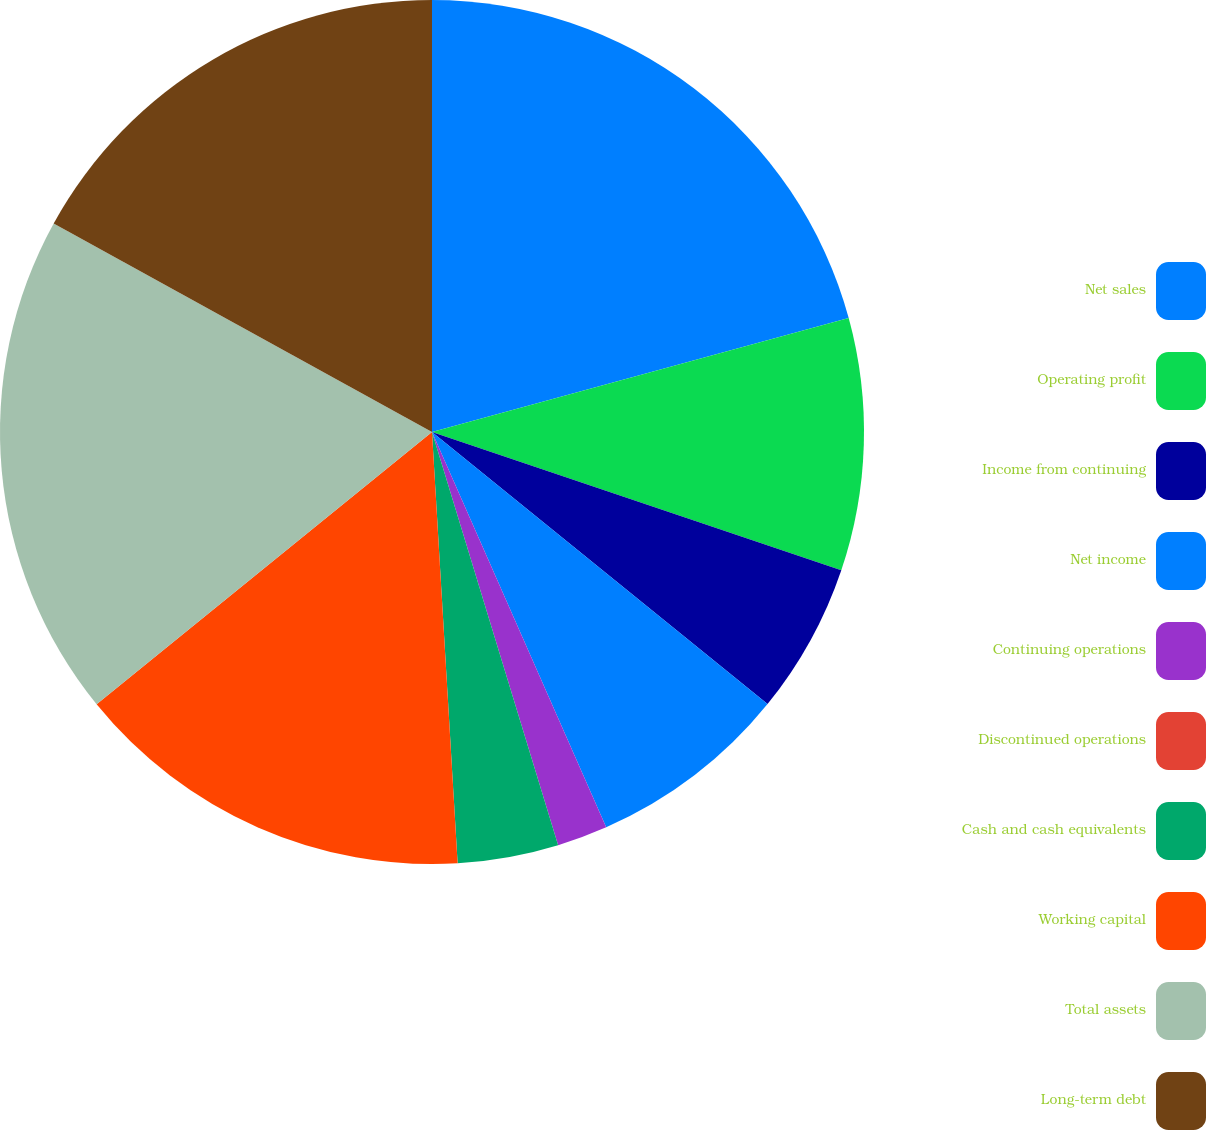Convert chart to OTSL. <chart><loc_0><loc_0><loc_500><loc_500><pie_chart><fcel>Net sales<fcel>Operating profit<fcel>Income from continuing<fcel>Net income<fcel>Continuing operations<fcel>Discontinued operations<fcel>Cash and cash equivalents<fcel>Working capital<fcel>Total assets<fcel>Long-term debt<nl><fcel>20.75%<fcel>9.43%<fcel>5.66%<fcel>7.55%<fcel>1.89%<fcel>0.0%<fcel>3.77%<fcel>15.09%<fcel>18.87%<fcel>16.98%<nl></chart> 